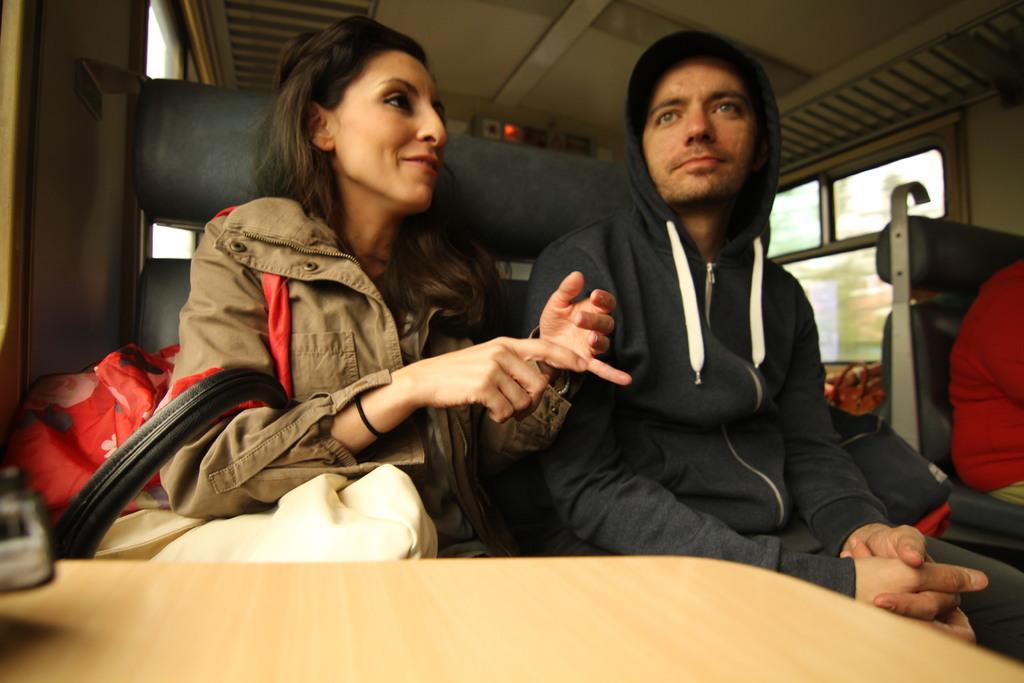Could you give a brief overview of what you see in this image? In this picture we can see some people are sitting on the seats inside of a vehicle. A woman in the jacket is explaining something. Behind the people there is an object and a window. Behind the window, they are looking like trees. 